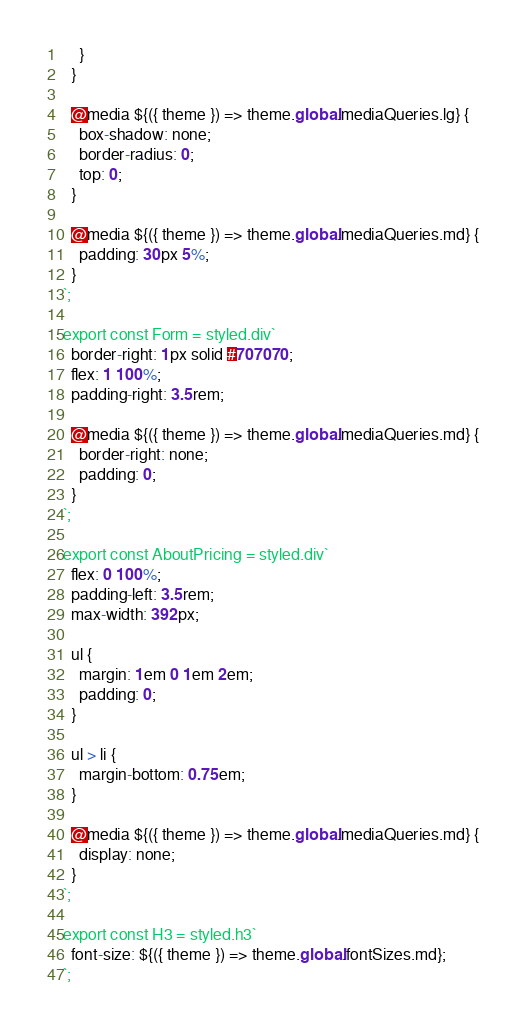<code> <loc_0><loc_0><loc_500><loc_500><_JavaScript_>    }
  }

  @media ${({ theme }) => theme.global.mediaQueries.lg} {
    box-shadow: none;
    border-radius: 0;
    top: 0;
  }

  @media ${({ theme }) => theme.global.mediaQueries.md} {
    padding: 30px 5%;
  }
`;

export const Form = styled.div`
  border-right: 1px solid #707070;
  flex: 1 100%;
  padding-right: 3.5rem;

  @media ${({ theme }) => theme.global.mediaQueries.md} {
    border-right: none;
    padding: 0;
  }
`;

export const AboutPricing = styled.div`
  flex: 0 100%;
  padding-left: 3.5rem;
  max-width: 392px;

  ul {
    margin: 1em 0 1em 2em;
    padding: 0;
  }

  ul > li {
    margin-bottom: 0.75em;
  }

  @media ${({ theme }) => theme.global.mediaQueries.md} {
    display: none;
  }
`;

export const H3 = styled.h3`
  font-size: ${({ theme }) => theme.global.fontSizes.md};
`;
</code> 